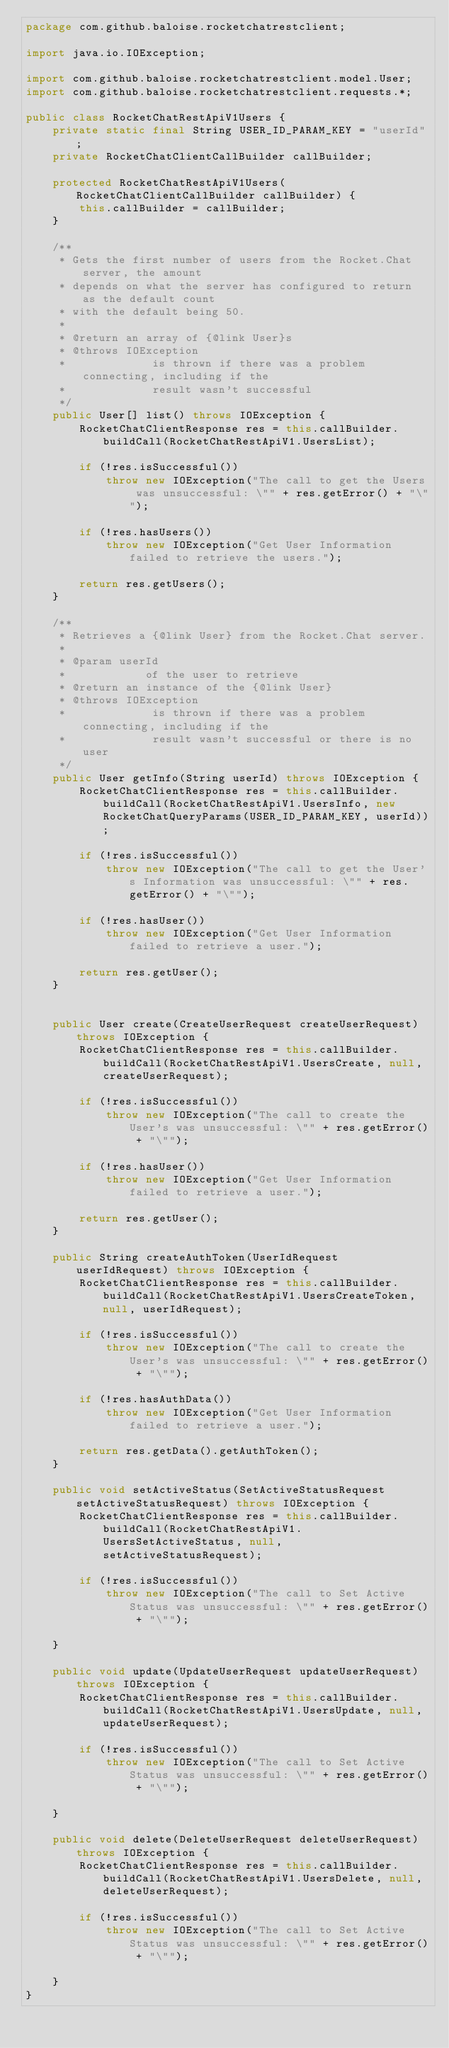Convert code to text. <code><loc_0><loc_0><loc_500><loc_500><_Java_>package com.github.baloise.rocketchatrestclient;

import java.io.IOException;

import com.github.baloise.rocketchatrestclient.model.User;
import com.github.baloise.rocketchatrestclient.requests.*;

public class RocketChatRestApiV1Users {
    private static final String USER_ID_PARAM_KEY = "userId";
    private RocketChatClientCallBuilder callBuilder;

    protected RocketChatRestApiV1Users(RocketChatClientCallBuilder callBuilder) {
        this.callBuilder = callBuilder;
    }
    
    /**
     * Gets the first number of users from the Rocket.Chat server, the amount
     * depends on what the server has configured to return as the default count
     * with the default being 50.
     *
     * @return an array of {@link User}s
     * @throws IOException
     *             is thrown if there was a problem connecting, including if the
     *             result wasn't successful
     */
    public User[] list() throws IOException {
        RocketChatClientResponse res = this.callBuilder.buildCall(RocketChatRestApiV1.UsersList);

        if (!res.isSuccessful())
            throw new IOException("The call to get the Users was unsuccessful: \"" + res.getError() + "\"");

        if (!res.hasUsers())
            throw new IOException("Get User Information failed to retrieve the users.");

        return res.getUsers();
    }

    /**
     * Retrieves a {@link User} from the Rocket.Chat server.
     *
     * @param userId
     *            of the user to retrieve
     * @return an instance of the {@link User}
     * @throws IOException
     *             is thrown if there was a problem connecting, including if the
     *             result wasn't successful or there is no user
     */
    public User getInfo(String userId) throws IOException {
        RocketChatClientResponse res = this.callBuilder.buildCall(RocketChatRestApiV1.UsersInfo, new RocketChatQueryParams(USER_ID_PARAM_KEY, userId));

        if (!res.isSuccessful())
            throw new IOException("The call to get the User's Information was unsuccessful: \"" + res.getError() + "\"");

        if (!res.hasUser())
            throw new IOException("Get User Information failed to retrieve a user.");

        return res.getUser();
    }


    public User create(CreateUserRequest createUserRequest) throws IOException {
        RocketChatClientResponse res = this.callBuilder.buildCall(RocketChatRestApiV1.UsersCreate, null, createUserRequest);

        if (!res.isSuccessful())
            throw new IOException("The call to create the User's was unsuccessful: \"" + res.getError() + "\"");

        if (!res.hasUser())
            throw new IOException("Get User Information failed to retrieve a user.");

        return res.getUser();
    }

    public String createAuthToken(UserIdRequest userIdRequest) throws IOException {
        RocketChatClientResponse res = this.callBuilder.buildCall(RocketChatRestApiV1.UsersCreateToken, null, userIdRequest);

        if (!res.isSuccessful())
            throw new IOException("The call to create the User's was unsuccessful: \"" + res.getError() + "\"");

        if (!res.hasAuthData())
            throw new IOException("Get User Information failed to retrieve a user.");

        return res.getData().getAuthToken();
    }

    public void setActiveStatus(SetActiveStatusRequest setActiveStatusRequest) throws IOException {
        RocketChatClientResponse res = this.callBuilder.buildCall(RocketChatRestApiV1.UsersSetActiveStatus, null, setActiveStatusRequest);

        if (!res.isSuccessful())
            throw new IOException("The call to Set Active Status was unsuccessful: \"" + res.getError() + "\"");

    }

    public void update(UpdateUserRequest updateUserRequest) throws IOException {
        RocketChatClientResponse res = this.callBuilder.buildCall(RocketChatRestApiV1.UsersUpdate, null, updateUserRequest);

        if (!res.isSuccessful())
            throw new IOException("The call to Set Active Status was unsuccessful: \"" + res.getError() + "\"");

    }

    public void delete(DeleteUserRequest deleteUserRequest) throws IOException {
        RocketChatClientResponse res = this.callBuilder.buildCall(RocketChatRestApiV1.UsersDelete, null, deleteUserRequest);

        if (!res.isSuccessful())
            throw new IOException("The call to Set Active Status was unsuccessful: \"" + res.getError() + "\"");

    }
}
</code> 